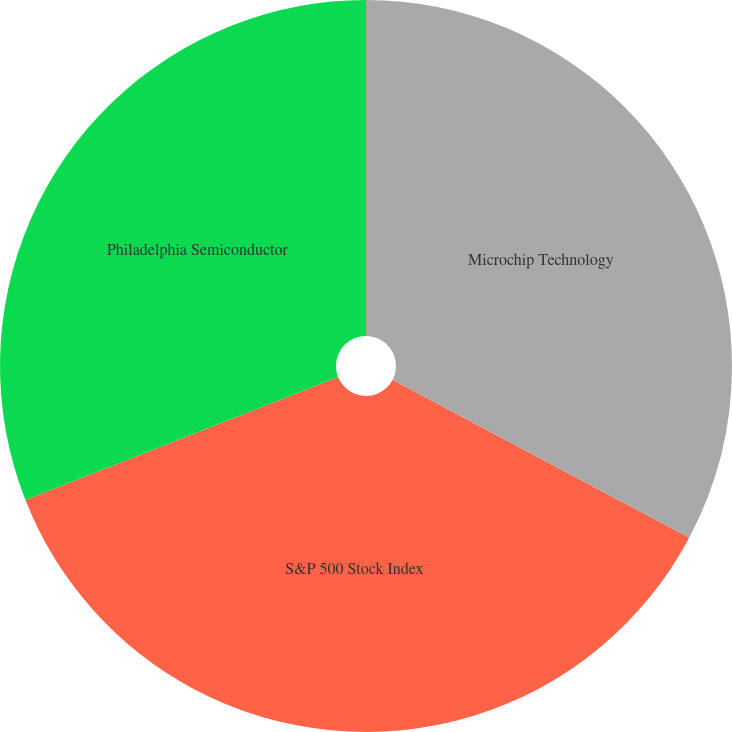Convert chart. <chart><loc_0><loc_0><loc_500><loc_500><pie_chart><fcel>Microchip Technology<fcel>S&P 500 Stock Index<fcel>Philadelphia Semiconductor<nl><fcel>32.78%<fcel>36.25%<fcel>30.97%<nl></chart> 